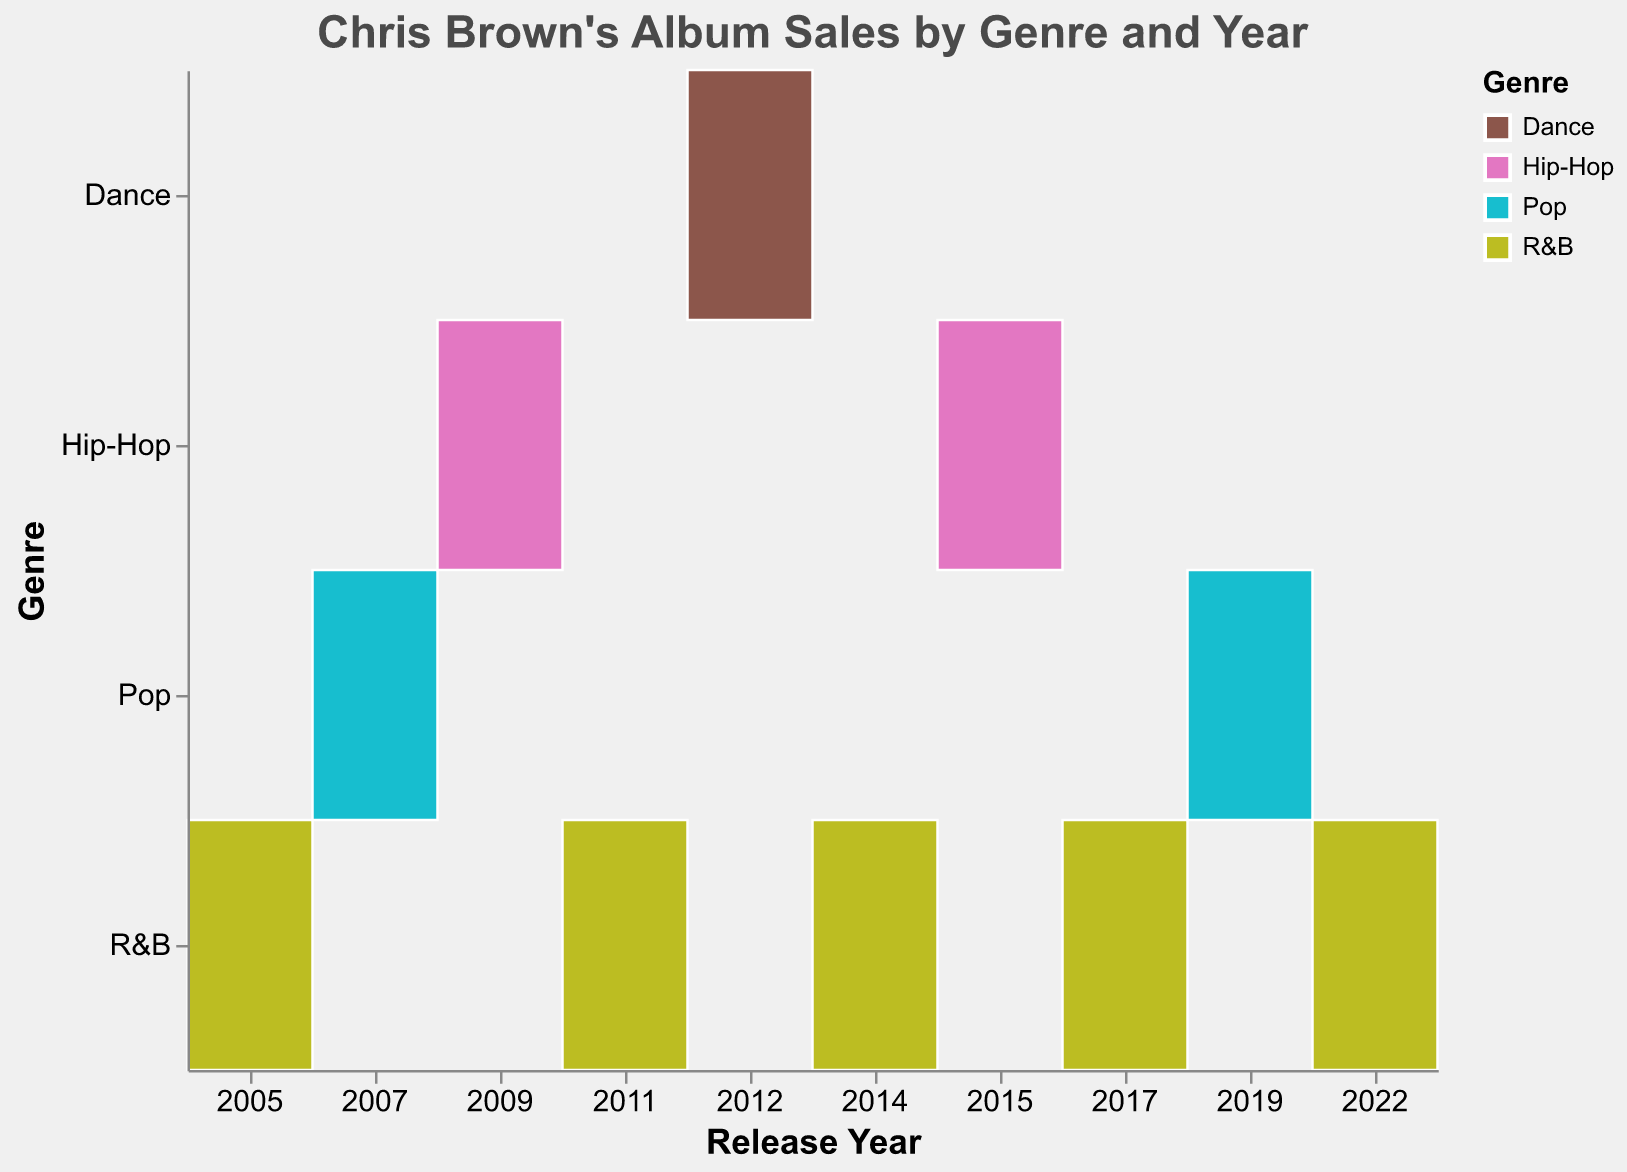What's the title of the chart? Look at the top of the figure where the title is displayed in bold text.
Answer: Chris Brown's Album Sales by Genre and Year Which year had the highest sales for an R&B album, and what was the album? Identify the largest rectangle in the R&B row and check which year it corresponds to.
Answer: 2005, Chris Brown How many genres are represented in the figure? Count the unique color categories or look at the legend to count the number of genres listed.
Answer: 4 Which genre has the fewest number of albums released, and how many albums were released in that genre? Identify the genre with the least number of rectangles (albums) visible in the plot.
Answer: Dance, 1 What is the total sales for Hip-Hop albums between 2009 and 2015? Add the sales for Hip-Hop albums released in 2009 and 2015. 2009: 1,000,000, 2015: 600,000. Total = 1,000,000 + 600,000.
Answer: 1,600,000 In which year did Chris Brown release albums in the most different genres? Check the year where the most different genres appear in the plot as distinct rows.
Answer: 2015 Compare the sales of "Exclusive" and "Indigo". Which album sold more and by how much? Refer to the sales amount in the tooltip of each album and subtract the smaller sales from the larger one. Sales for "Exclusive" is 2,500,000 and "Indigo" is 900,000. Difference = 2,500,000 - 900,000.
Answer: Exclusive, by 1,600,000 What is the average sales per album in Pop genre? Add the sales of all Pop albums and divide by the number of Pop albums. Sales: 2,500,000 (Exclusive) + 900,000 (Indigo) = 3,400,000. Pop albums = 2. Average = 3,400,000 / 2.
Answer: 1,700,000 Which R&B album released after 2005 has the highest sales, and what are those sales? Check the largest rectangle in the R&B row for years after 2005 and find the tooltip information for sales.
Answer: F.A.M.E., 1,500,000 